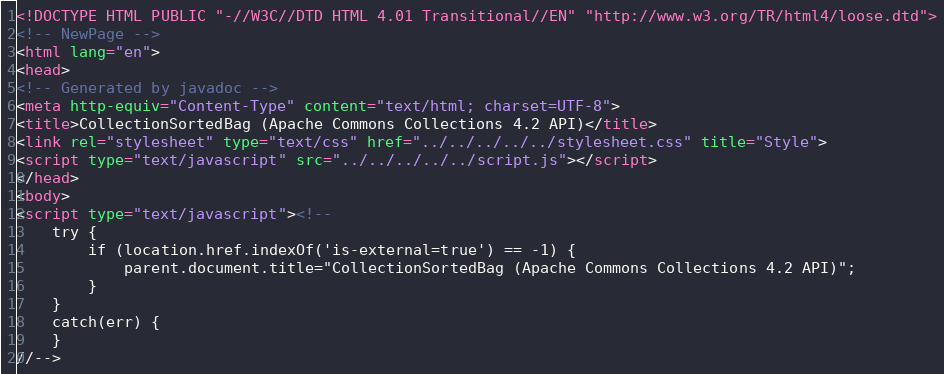<code> <loc_0><loc_0><loc_500><loc_500><_HTML_><!DOCTYPE HTML PUBLIC "-//W3C//DTD HTML 4.01 Transitional//EN" "http://www.w3.org/TR/html4/loose.dtd">
<!-- NewPage -->
<html lang="en">
<head>
<!-- Generated by javadoc -->
<meta http-equiv="Content-Type" content="text/html; charset=UTF-8">
<title>CollectionSortedBag (Apache Commons Collections 4.2 API)</title>
<link rel="stylesheet" type="text/css" href="../../../../../stylesheet.css" title="Style">
<script type="text/javascript" src="../../../../../script.js"></script>
</head>
<body>
<script type="text/javascript"><!--
    try {
        if (location.href.indexOf('is-external=true') == -1) {
            parent.document.title="CollectionSortedBag (Apache Commons Collections 4.2 API)";
        }
    }
    catch(err) {
    }
//--></code> 